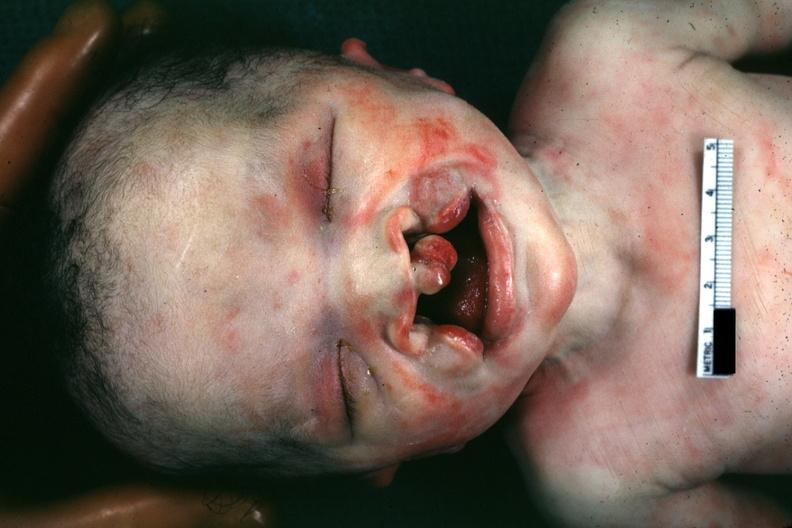s face present?
Answer the question using a single word or phrase. Yes 